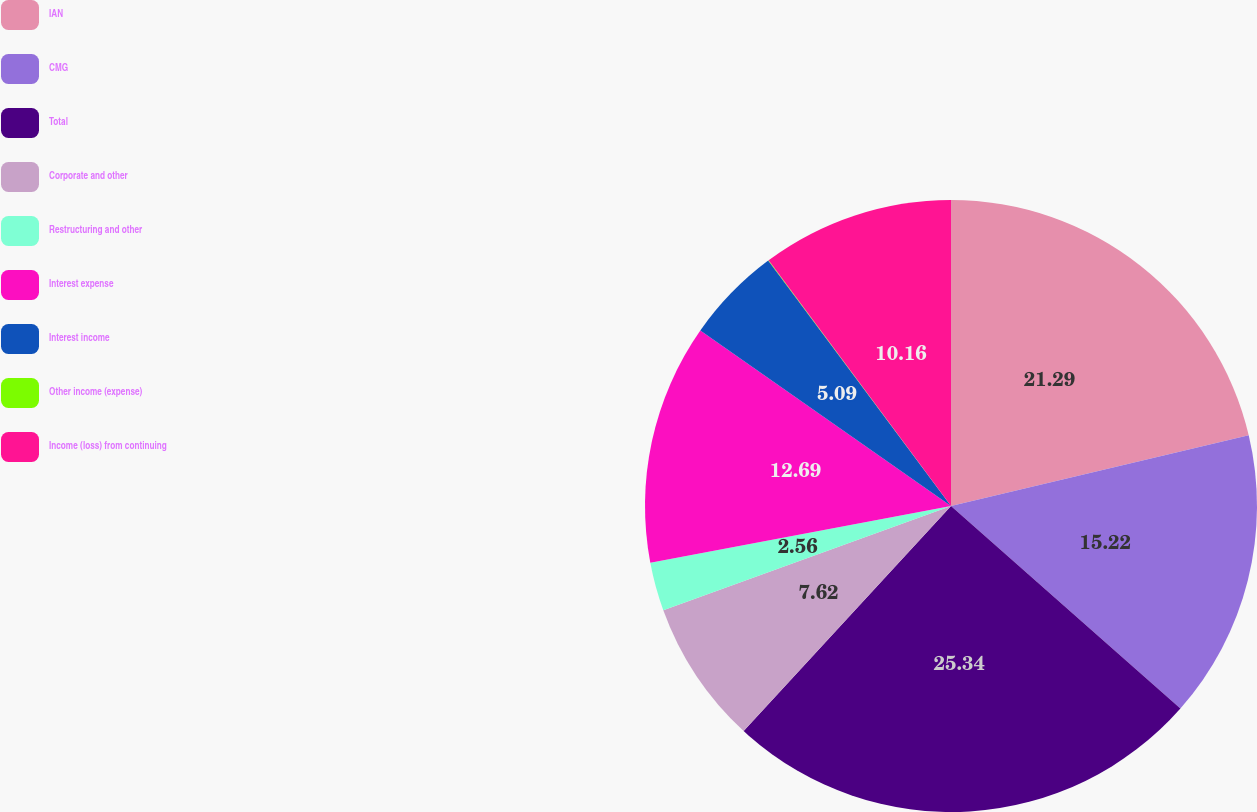<chart> <loc_0><loc_0><loc_500><loc_500><pie_chart><fcel>IAN<fcel>CMG<fcel>Total<fcel>Corporate and other<fcel>Restructuring and other<fcel>Interest expense<fcel>Interest income<fcel>Other income (expense)<fcel>Income (loss) from continuing<nl><fcel>21.29%<fcel>15.22%<fcel>25.34%<fcel>7.62%<fcel>2.56%<fcel>12.69%<fcel>5.09%<fcel>0.03%<fcel>10.16%<nl></chart> 